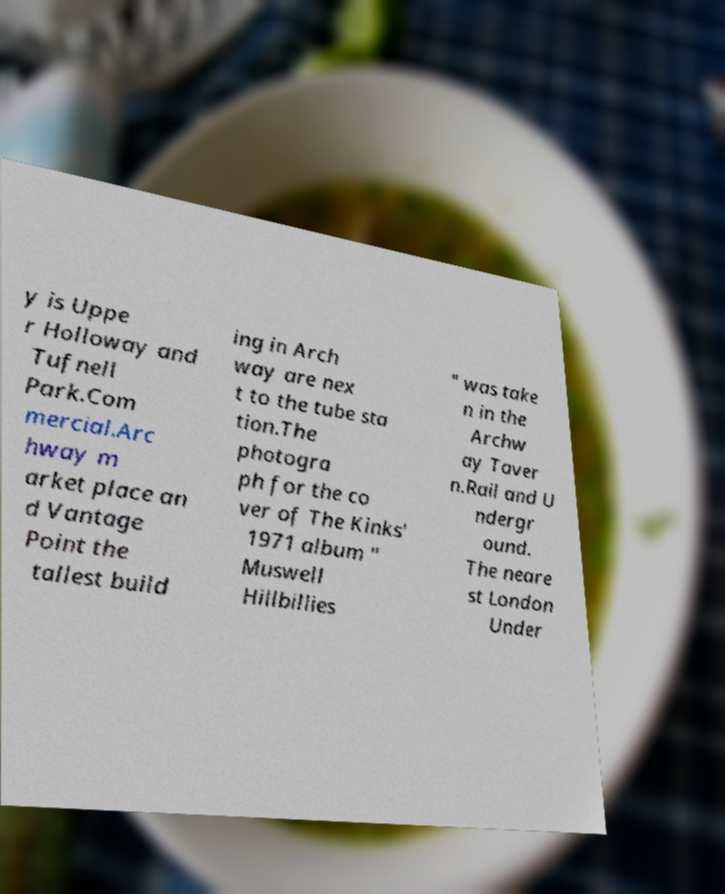Please read and relay the text visible in this image. What does it say? y is Uppe r Holloway and Tufnell Park.Com mercial.Arc hway m arket place an d Vantage Point the tallest build ing in Arch way are nex t to the tube sta tion.The photogra ph for the co ver of The Kinks' 1971 album " Muswell Hillbillies " was take n in the Archw ay Taver n.Rail and U ndergr ound. The neare st London Under 